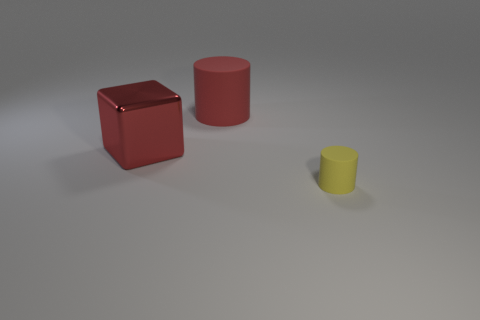Is there anything else that is the same shape as the red metallic object?
Provide a succinct answer. No. What is the color of the thing that is the same material as the tiny cylinder?
Your response must be concise. Red. What number of yellow things are small cylinders or cylinders?
Make the answer very short. 1. Are there more small yellow objects than red spheres?
Your response must be concise. Yes. How many things are red matte objects that are left of the yellow rubber cylinder or things in front of the large rubber cylinder?
Your answer should be compact. 3. Do the yellow thing and the red cylinder have the same material?
Your answer should be compact. Yes. What is the red thing left of the matte object that is behind the big red metal thing made of?
Offer a very short reply. Metal. Is the number of yellow cylinders on the right side of the large rubber object greater than the number of large red shiny cubes?
Provide a succinct answer. No. How many other things are the same size as the red cylinder?
Ensure brevity in your answer.  1. Is the color of the large metallic object the same as the small thing?
Ensure brevity in your answer.  No. 